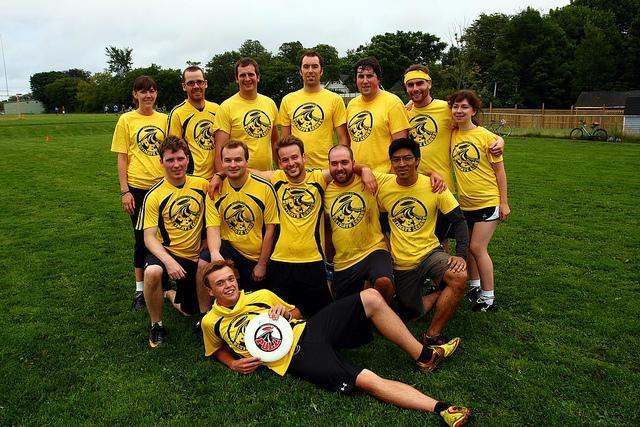How many players are there?
Give a very brief answer. 13. How many people are visible?
Give a very brief answer. 13. How many people are between the two orange buses in the image?
Give a very brief answer. 0. 